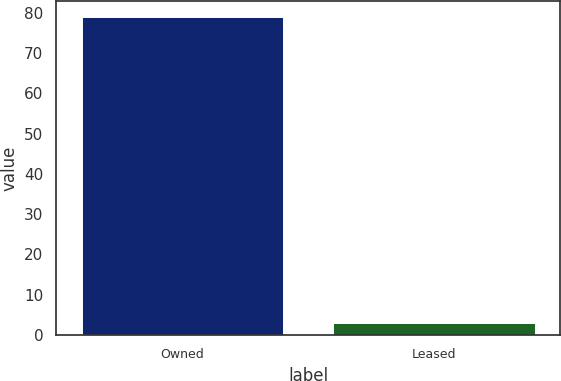Convert chart. <chart><loc_0><loc_0><loc_500><loc_500><bar_chart><fcel>Owned<fcel>Leased<nl><fcel>79<fcel>3<nl></chart> 